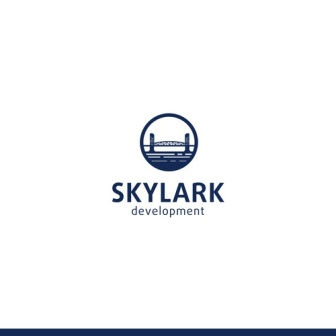Can you create a marketing tagline for 'Skylark Development'? "Skylark Development: Building Bridges to Tomorrow's Skyline."  How might Skylark Development promote sustainable practices in their projects? Skylark Development could champion sustainability by incorporating green building materials, implementing renewable energy sources like solar and wind power, and designing buildings with energy-efficient systems. They might also focus on creating green spaces, such as parks and rooftop gardens, to enhance urban biodiversity and offer residents recreation areas. Water conservation measures, like rainwater harvesting and greywater recycling systems, could be standard in their projects. Additionally, promoting walkability and the use of public transportation would reduce the carbon footprint of their developments.  What historical influences might the architecture and design of the city in the logo draw from? The architecture and design of the city depicted in the Skylark Development logo might draw influence from a variety of historical periods. The sleek, modern elements suggest a nod to early 20th-century modernism, characterized by clean lines and functional design principles. The inclusion of a bridge suggests engineering marvels like those from the Industrial Revolution, incorporating robust steel frameworks and innovative construction techniques. Additionally, there could be subtle influences from classical architecture in the proportions and symmetry, blended seamlessly with contemporary urban design to create a harmonious and timeless aesthetic. 